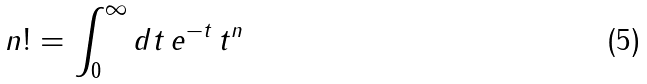Convert formula to latex. <formula><loc_0><loc_0><loc_500><loc_500>n ! = \int _ { 0 } ^ { \infty } d t \, e ^ { - t } \, t ^ { n }</formula> 